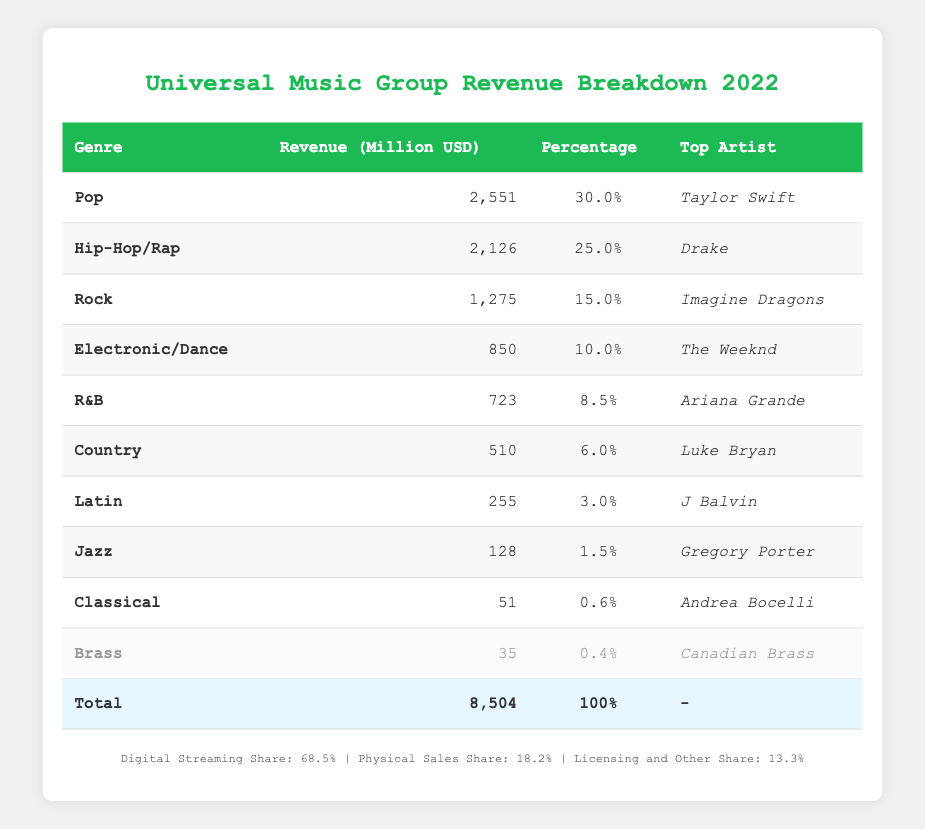What is the total revenue for Universal Music Group in 2022? The total revenue is provided in the table as 8,504 million USD.
Answer: 8,504 million USD Which genre generated the highest revenue? From the table, Pop has the highest revenue with 2,551 million USD.
Answer: Pop What percentage of the total revenue is attributed to Hip-Hop/Rap? The percentage for Hip-Hop/Rap is directly stated in the table as 25.0%.
Answer: 25.0% What is the combined revenue of Rock and R&B? The revenue for Rock is 1,275 million USD and for R&B is 723 million USD. Combined, they total 1,275 + 723 = 1,998 million USD.
Answer: 1,998 million USD Is the revenue for Brass greater than that of Jazz? The revenue for Brass is 35 million USD and for Jazz is 128 million USD. Since 35 < 128, the statement is false.
Answer: No Which genre has the lowest percentage of revenue? Brass has the lowest percentage of revenue as shown in the table with 0.4%.
Answer: Brass If we consider only the top three genres by revenue, what percentage of the total revenue do they account for? The top three genres are Pop (30.0%), Hip-Hop/Rap (25.0%), and Rock (15.0%). Their combined percentage is 30.0 + 25.0 + 15.0 = 70.0%.
Answer: 70.0% Has the revenue for Electronic/Dance genre surpassed that of both Country and Latin genres combined? Electronic/Dance revenue is 850 million USD, while Country and Latin together total 510 million USD + 255 million USD = 765 million USD. Since 850 > 765, the answer is yes.
Answer: Yes What is the average revenue of genres classified as either Country, Latin, Jazz, or Classical? The revenues from those genres are Country (510 million USD), Latin (255 million USD), Jazz (128 million USD), and Classical (51 million USD). Their total is 510 + 255 + 128 + 51 = 944 million USD. The average is 944 / 4 = 236 million USD.
Answer: 236 million USD 